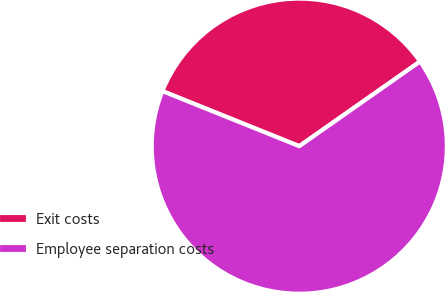<chart> <loc_0><loc_0><loc_500><loc_500><pie_chart><fcel>Exit costs<fcel>Employee separation costs<nl><fcel>34.18%<fcel>65.82%<nl></chart> 